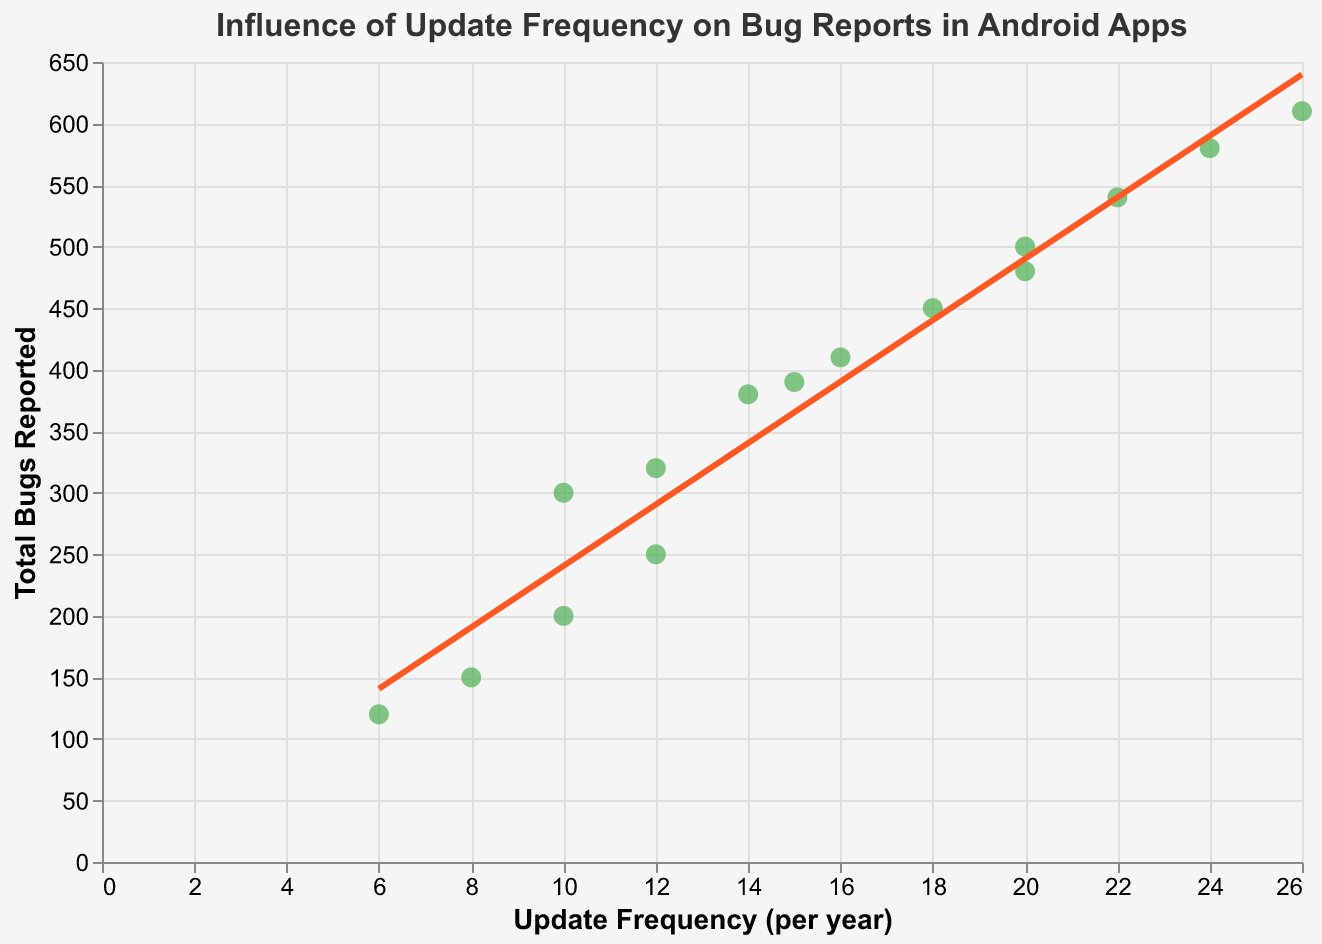What's the title of the figure? The title is displayed at the top of the figure and it reads "Influence of Update Frequency on Bug Reports in Android Apps".
Answer: Influence of Update Frequency on Bug Reports in Android Apps What does the trend line represent? The trend line represents the overall relationship between the update frequency per year and the total number of bugs reported across all the apps.
Answer: Relationship between update frequency and total bugs How many apps have an update frequency of 12 per year? Looking at the x-axis, find the data points that correspond to update frequency of 12 and count them. There are two such points.
Answer: 2 apps Which app has the highest number of bugs reported, and what is its update frequency? From the data points, the app with the highest y-value (total bugs reported) is TikTok, which is 610 bugs with an update frequency of 26 per year.
Answer: TikTok, 26 updates per year What are the axis titles for the x and y axes? The x-axis title is "Update Frequency (per year)" and the y-axis title is "Total Bugs Reported".
Answer: Update Frequency (per year), Total Bugs Reported Which app has the lowest update frequency and how many bugs does it report? The app with the lowest update frequency on the x-axis is Gmail with 6 updates/year and it reports 120 bugs.
Answer: Gmail, 120 bugs Compare the total bugs reported by Facebook and LinkedIn. Which one has more bugs and by how much? Facebook reports 300 bugs and LinkedIn reports 200 bugs. The difference is 300 - 200 = 100 bugs.
Answer: Facebook, 100 bugs more Is there a positive or negative correlation between update frequency and total bugs reported based on the trend line? The trend line appears to slope upwards from left to right, indicating a positive correlation.
Answer: Positive correlation Which app has the closest number of bugs reported to the mean of all reported bugs? Calculate the mean of all reported bugs: (320 + 580 + 450 + 610 + 390 + 480 + 300 + 150 + 380 + 120 + 500 + 540 + 410 + 250 + 200)/15 = 373.33. The app closest to this mean is Zoom with 380 bugs reported.
Answer: Zoom How many apps report more than 500 bugs and what are their update frequencies? Count the number of data points where the y-value (total bugs reported) is greater than 500. The apps are Instagram (24 updates), TikTok (26 updates), Uber (20 updates), and Netflix (22 updates).
Answer: 4 apps: Instagram (24), TikTok (26), Uber (20), Netflix (22) 